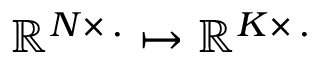Convert formula to latex. <formula><loc_0><loc_0><loc_500><loc_500>\mathbb { R } ^ { N \times \, . } \mapsto \mathbb { R } ^ { K \times \, . }</formula> 